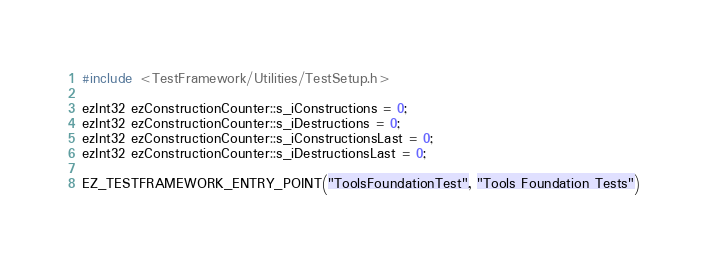<code> <loc_0><loc_0><loc_500><loc_500><_C++_>#include <TestFramework/Utilities/TestSetup.h>

ezInt32 ezConstructionCounter::s_iConstructions = 0;
ezInt32 ezConstructionCounter::s_iDestructions = 0;
ezInt32 ezConstructionCounter::s_iConstructionsLast = 0;
ezInt32 ezConstructionCounter::s_iDestructionsLast = 0;

EZ_TESTFRAMEWORK_ENTRY_POINT("ToolsFoundationTest", "Tools Foundation Tests")
</code> 